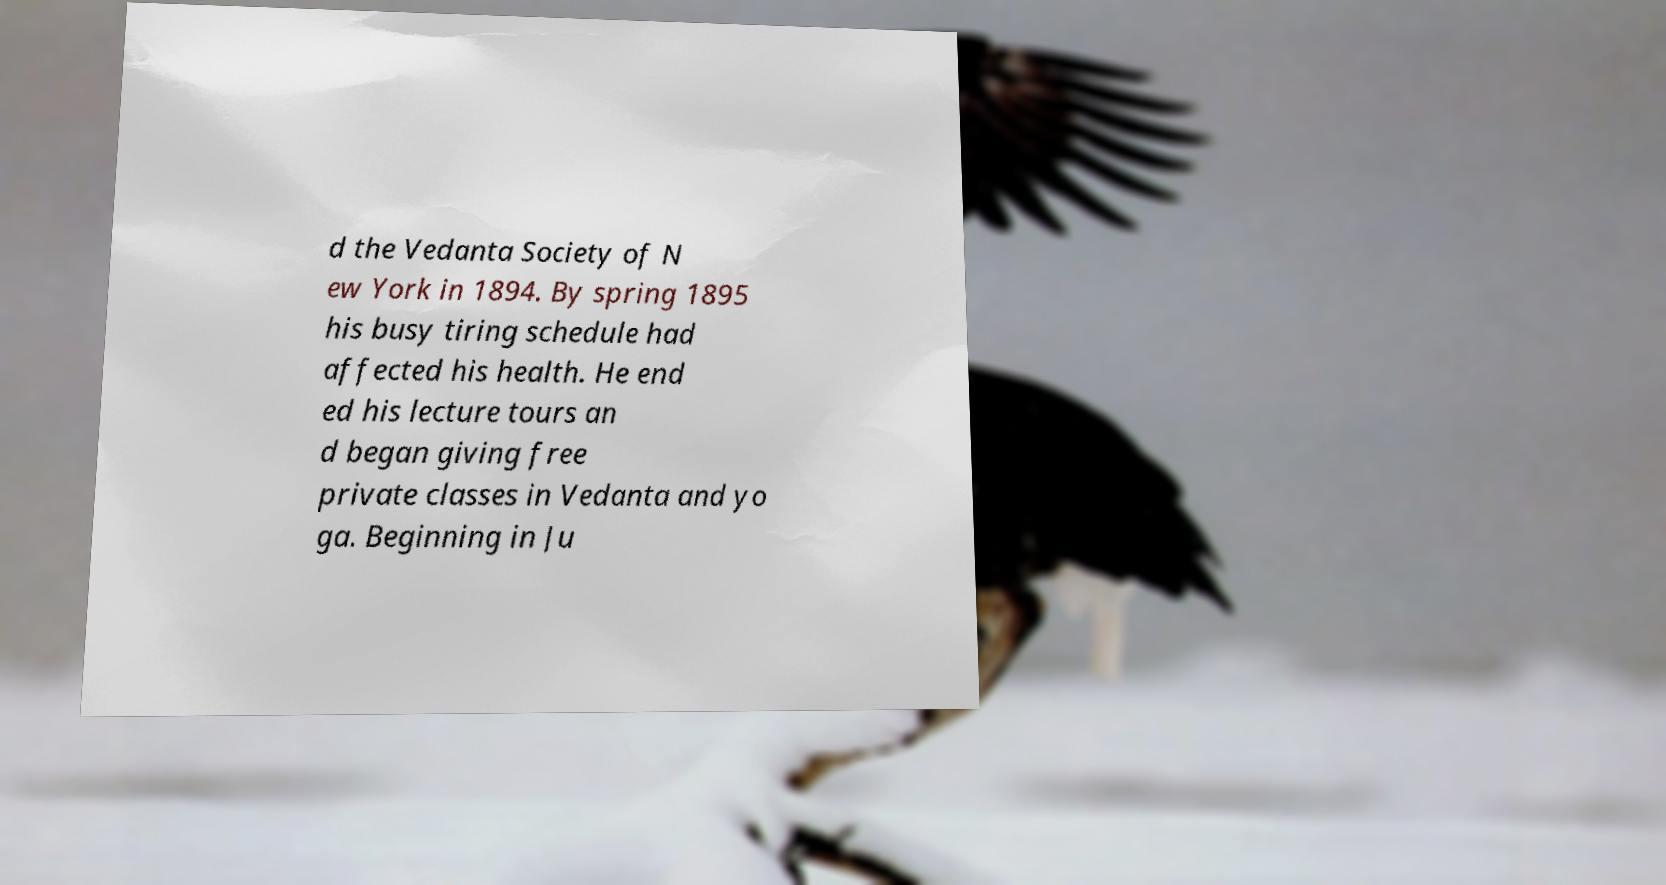Please identify and transcribe the text found in this image. d the Vedanta Society of N ew York in 1894. By spring 1895 his busy tiring schedule had affected his health. He end ed his lecture tours an d began giving free private classes in Vedanta and yo ga. Beginning in Ju 